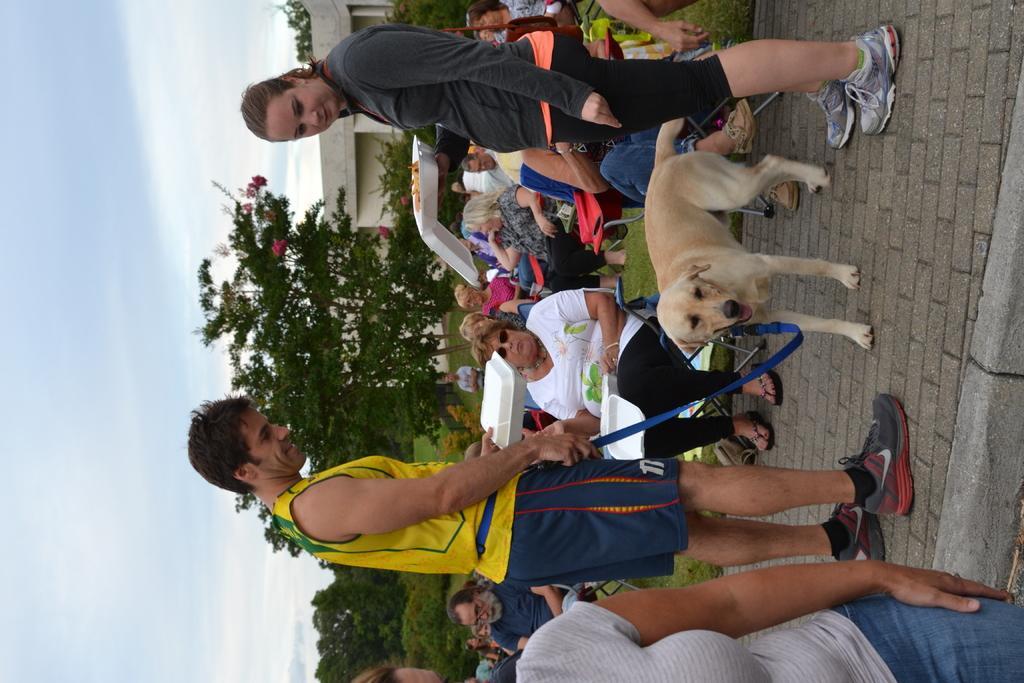Please provide a concise description of this image. Here a man is standing and holding a dog and there are women sitting on the chairs and looking at this right side there is a woman standing behind her there is a building,trees and a sunny day 